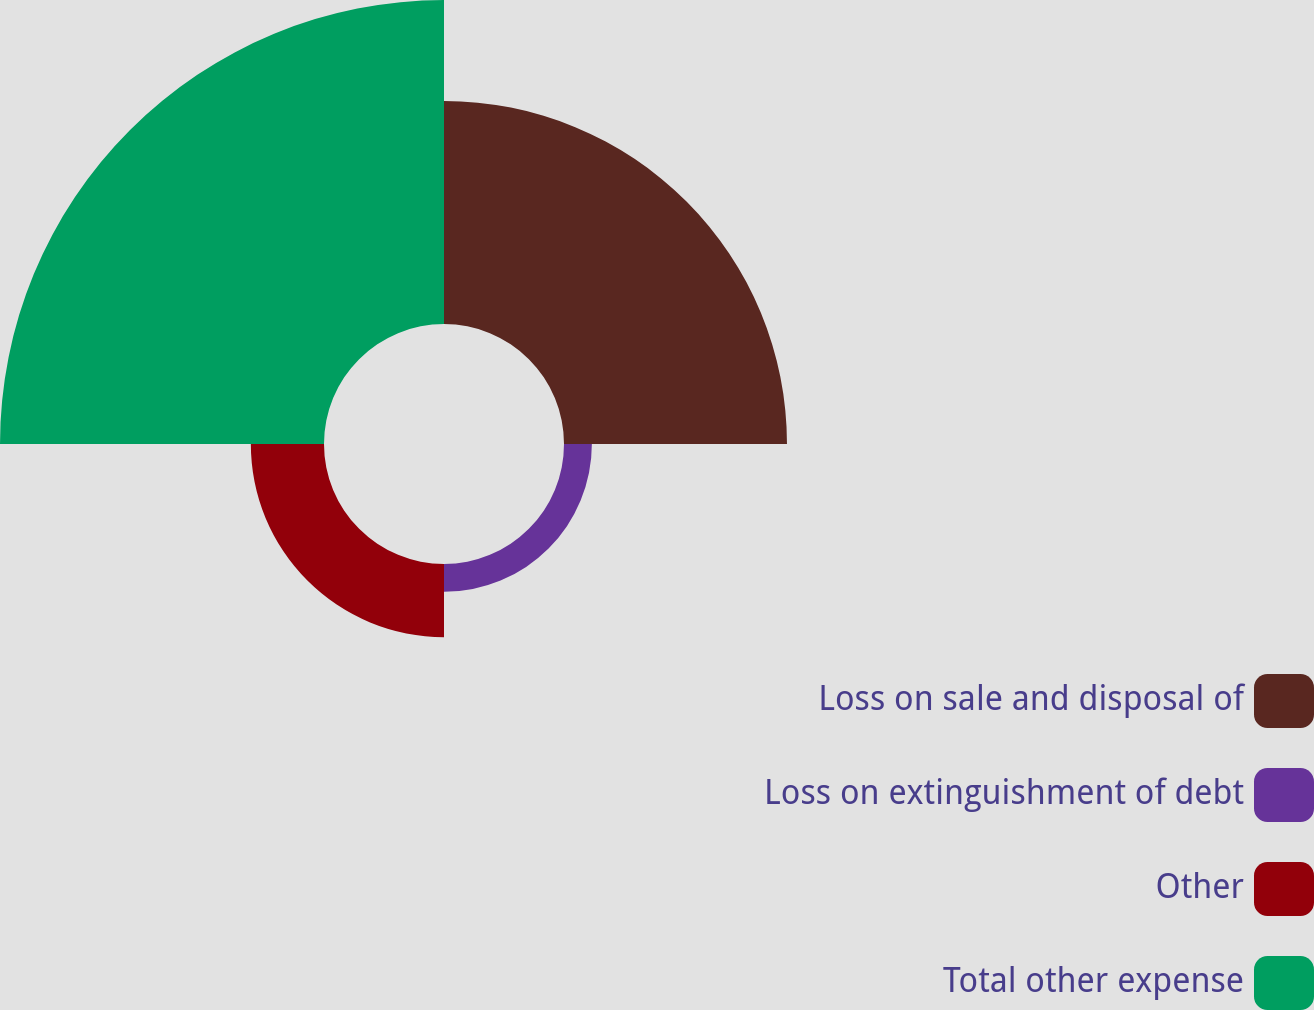Convert chart to OTSL. <chart><loc_0><loc_0><loc_500><loc_500><pie_chart><fcel>Loss on sale and disposal of<fcel>Loss on extinguishment of debt<fcel>Other<fcel>Total other expense<nl><fcel>34.41%<fcel>4.3%<fcel>11.29%<fcel>50.0%<nl></chart> 